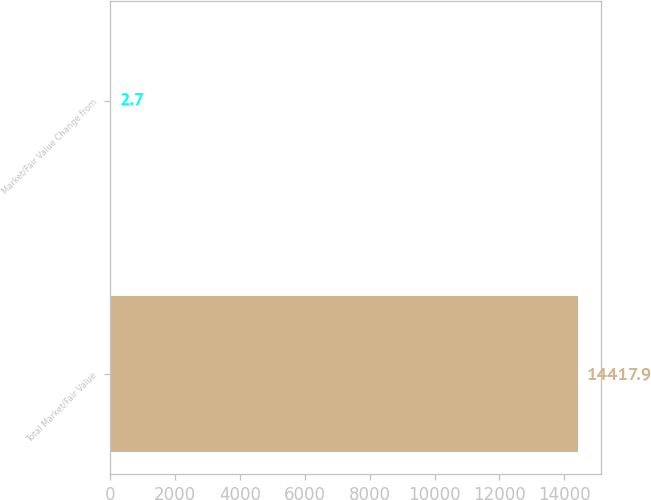Convert chart to OTSL. <chart><loc_0><loc_0><loc_500><loc_500><bar_chart><fcel>Total Market/Fair Value<fcel>Market/Fair Value Change from<nl><fcel>14417.9<fcel>2.7<nl></chart> 